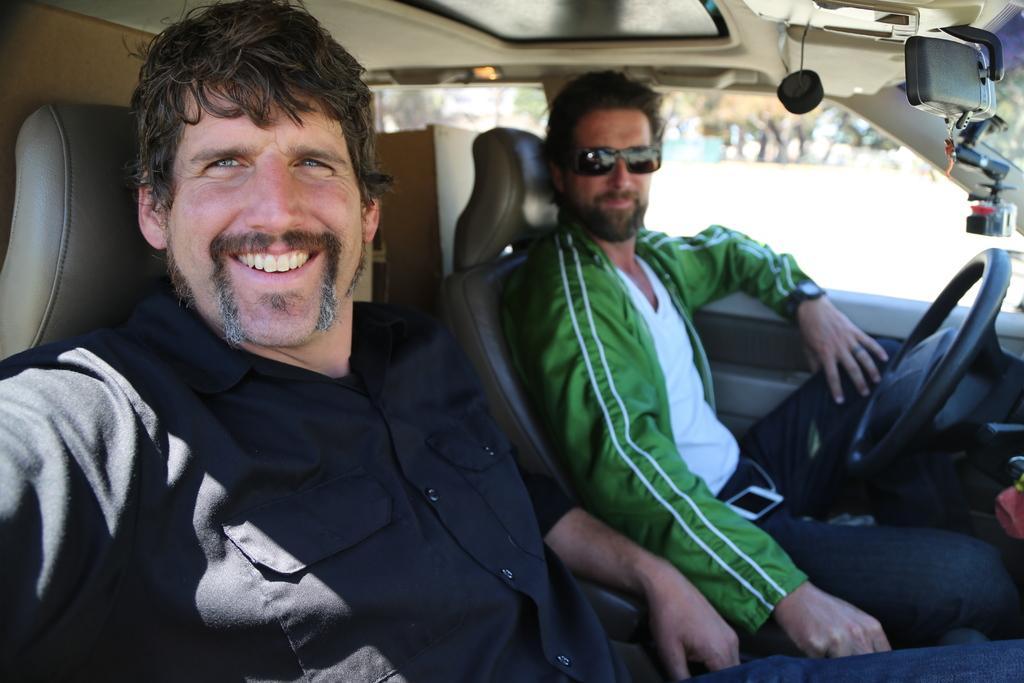Could you give a brief overview of what you see in this image? This image consists of two persons sitting in a car. On the left, the man is wearing a black shirt. On the right, the man is wearing a green jacket. At the top, there is a roof of the car. 